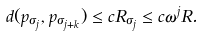Convert formula to latex. <formula><loc_0><loc_0><loc_500><loc_500>d ( p _ { \sigma _ { j } } , p _ { \sigma _ { j + k } } ) \leq c R _ { \sigma _ { j } } \leq c \omega ^ { j } R .</formula> 